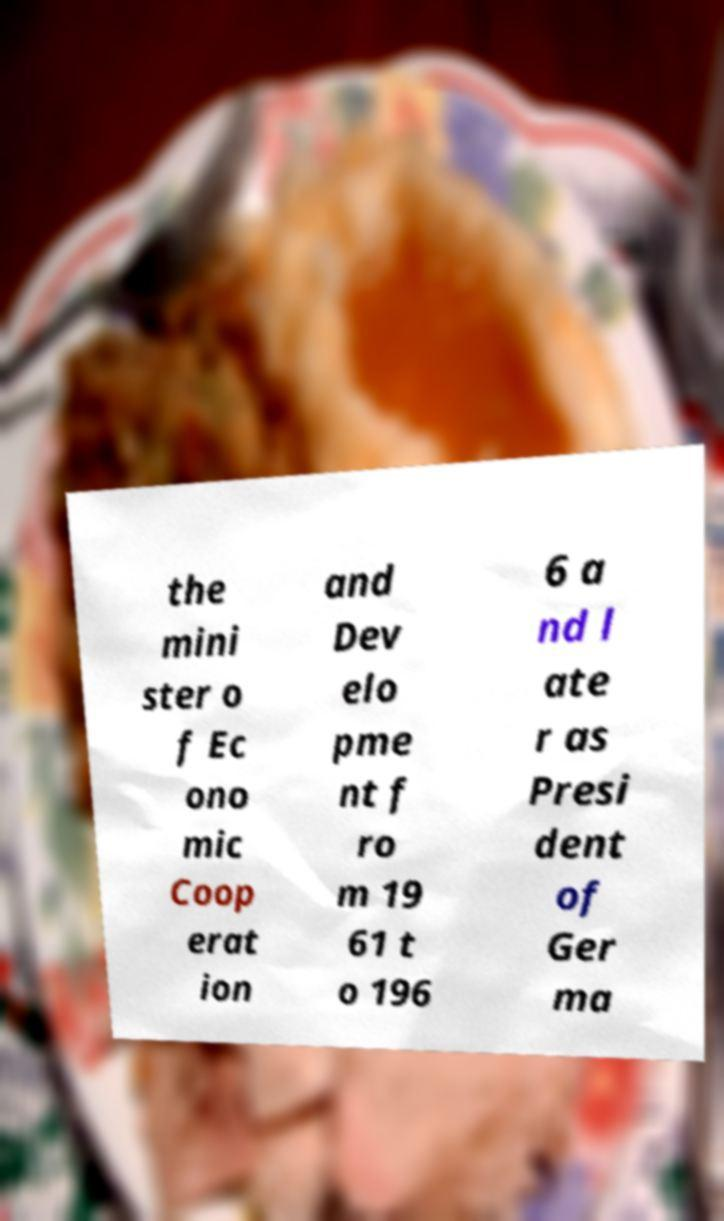Please read and relay the text visible in this image. What does it say? the mini ster o f Ec ono mic Coop erat ion and Dev elo pme nt f ro m 19 61 t o 196 6 a nd l ate r as Presi dent of Ger ma 